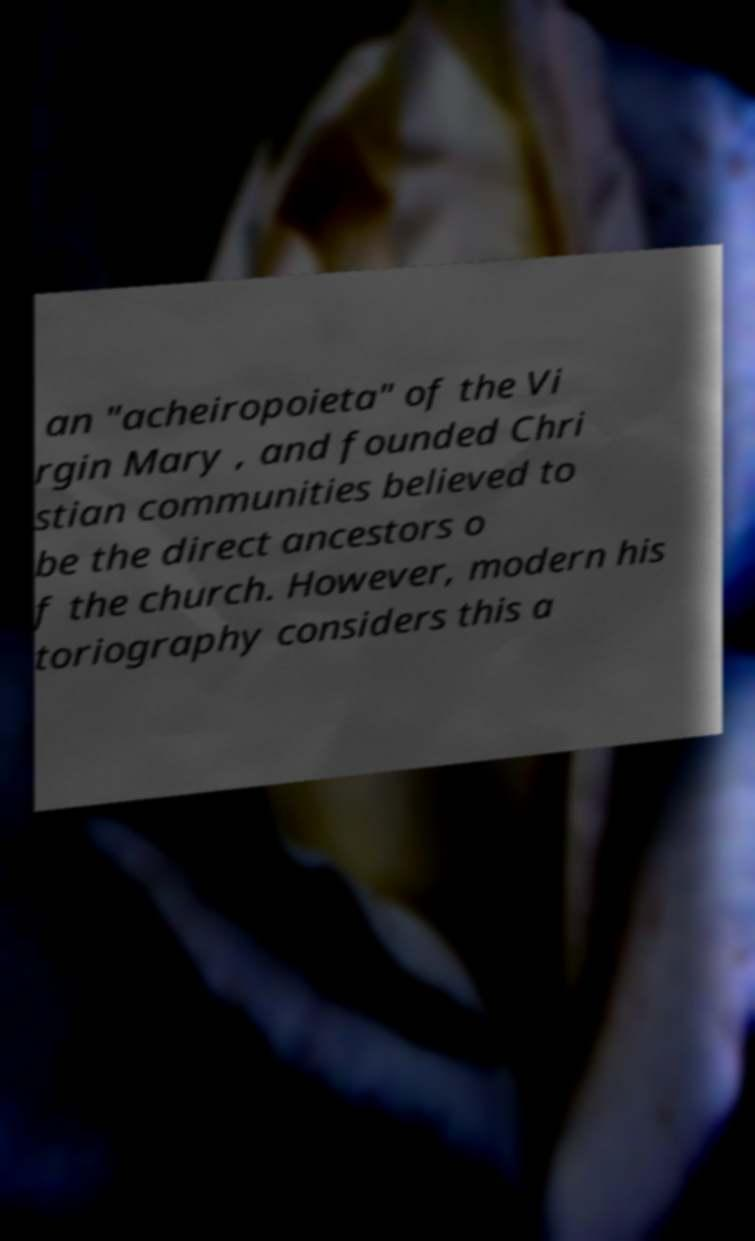Please identify and transcribe the text found in this image. an "acheiropoieta" of the Vi rgin Mary , and founded Chri stian communities believed to be the direct ancestors o f the church. However, modern his toriography considers this a 